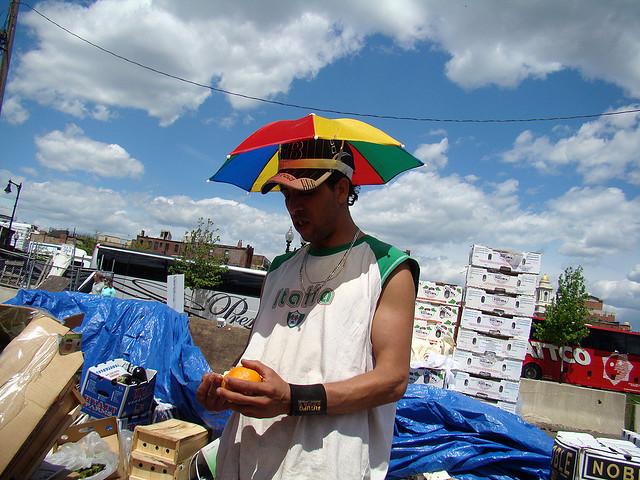How many hats is the man wearing?
Write a very short answer. 2. Is there any thing stacked up?
Give a very brief answer. Yes. How many buses are in the background?
Give a very brief answer. 2. Is the man holding tomato?
Be succinct. No. 